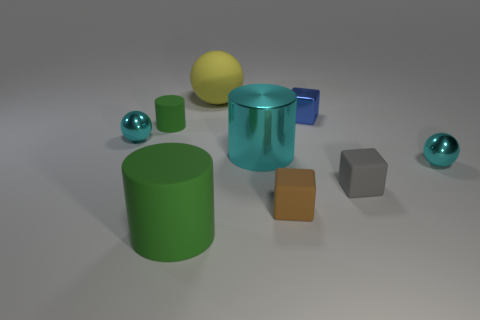How many things are large spheres or small balls?
Your response must be concise. 3. There is a cyan object that is on the left side of the tiny green thing; what size is it?
Give a very brief answer. Small. There is a small thing that is behind the shiny cylinder and on the right side of the yellow rubber thing; what color is it?
Your response must be concise. Blue. Is the material of the cylinder that is behind the big cyan metallic object the same as the tiny brown object?
Make the answer very short. Yes. There is a big metal cylinder; is it the same color as the metal ball on the right side of the gray rubber cube?
Your response must be concise. Yes. There is a metal cylinder; are there any big yellow objects right of it?
Your answer should be very brief. No. There is a green cylinder that is in front of the tiny gray matte object; is it the same size as the rubber cube right of the blue cube?
Your answer should be very brief. No. Are there any red matte balls that have the same size as the gray block?
Provide a short and direct response. No. Does the tiny cyan object to the right of the big green cylinder have the same shape as the large yellow rubber thing?
Your answer should be very brief. Yes. What is the cyan sphere that is left of the brown matte object made of?
Provide a succinct answer. Metal. 